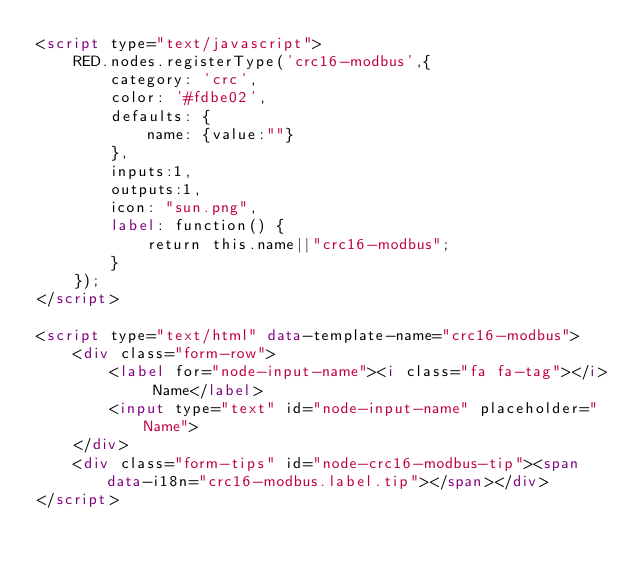Convert code to text. <code><loc_0><loc_0><loc_500><loc_500><_HTML_><script type="text/javascript">
    RED.nodes.registerType('crc16-modbus',{
        category: 'crc',
        color: '#fdbe02',
        defaults: {
            name: {value:""}
        },
        inputs:1,
        outputs:1,
        icon: "sun.png",
        label: function() {
            return this.name||"crc16-modbus";
        }
    });
</script>

<script type="text/html" data-template-name="crc16-modbus">
    <div class="form-row">
        <label for="node-input-name"><i class="fa fa-tag"></i> Name</label>
        <input type="text" id="node-input-name" placeholder="Name">
    </div>
    <div class="form-tips" id="node-crc16-modbus-tip"><span data-i18n="crc16-modbus.label.tip"></span></div>
</script>

</code> 